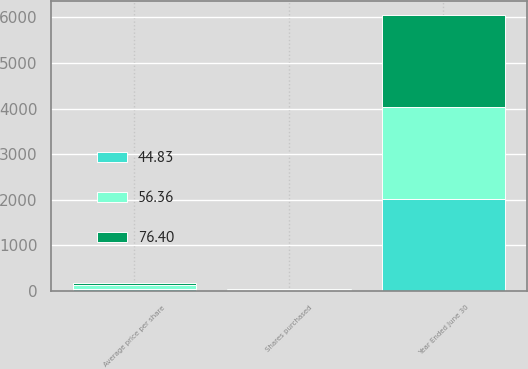<chart> <loc_0><loc_0><loc_500><loc_500><stacked_bar_chart><ecel><fcel>Year Ended June 30<fcel>Shares purchased<fcel>Average price per share<nl><fcel>56.36<fcel>2018<fcel>13<fcel>76.4<nl><fcel>44.83<fcel>2017<fcel>13<fcel>56.36<nl><fcel>76.4<fcel>2016<fcel>15<fcel>44.83<nl></chart> 